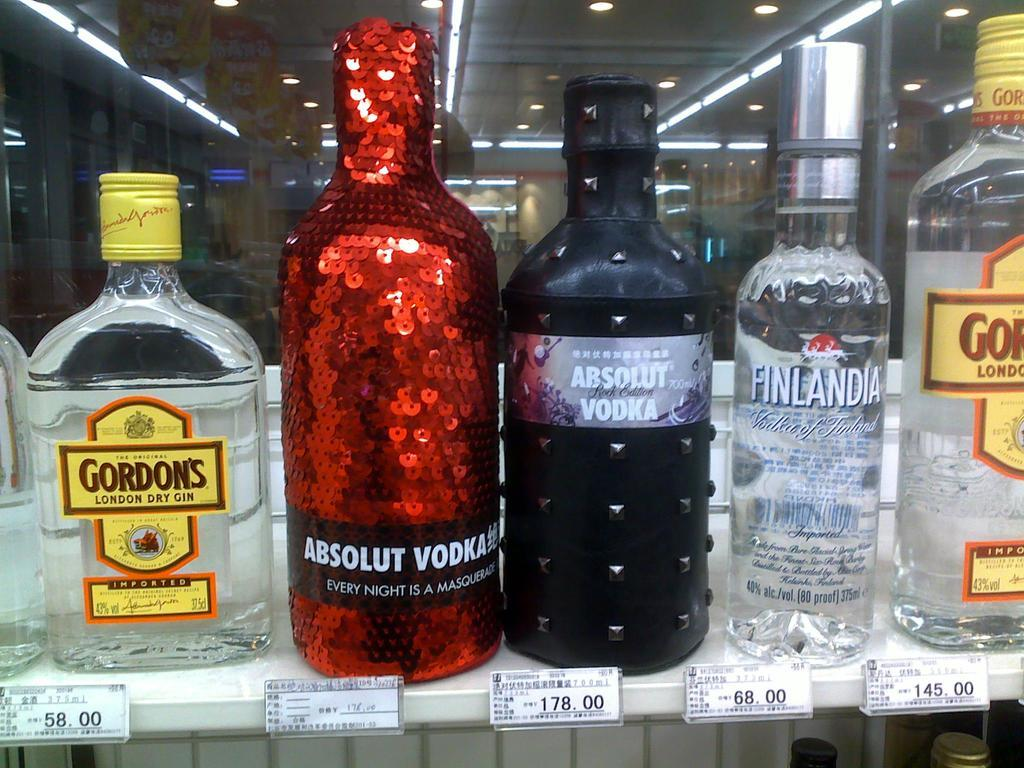Provide a one-sentence caption for the provided image. A bottle of Gordon's dry gin sits next to a sequined bottle of vodka. 